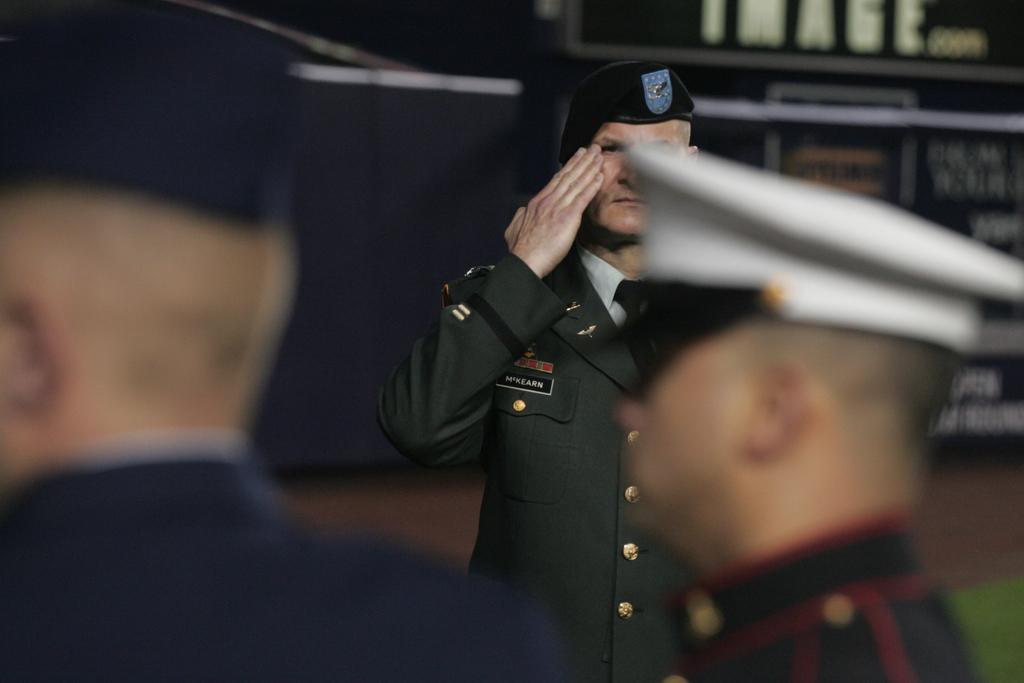Describe this image in one or two sentences. In the center of the image we can see three persons are standing and they are wearing caps. And they are in different color costumes. In the background there is a wall, banners and a few other objects. 